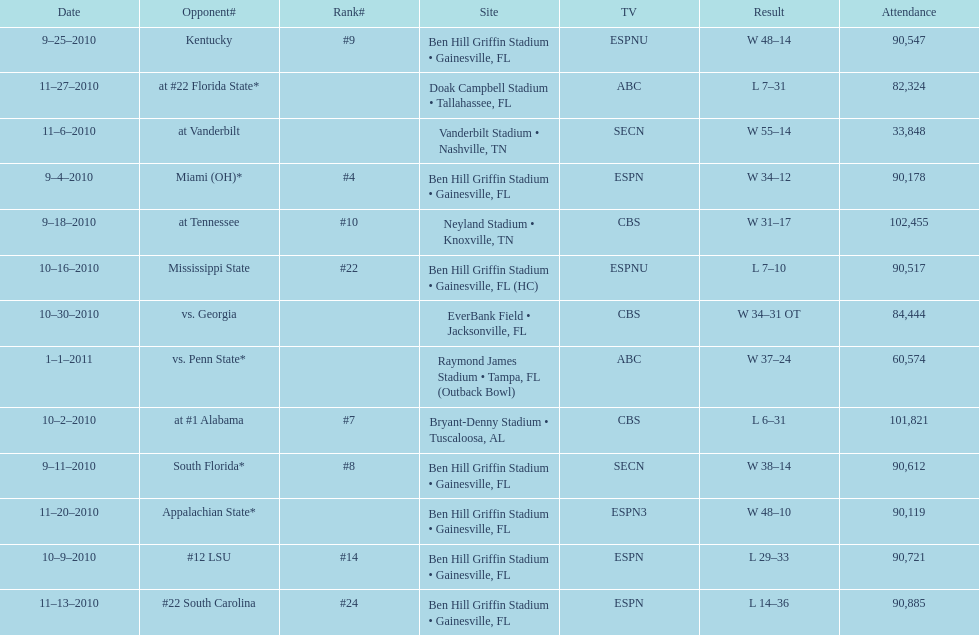How many games were played at the ben hill griffin stadium during the 2010-2011 season? 7. 